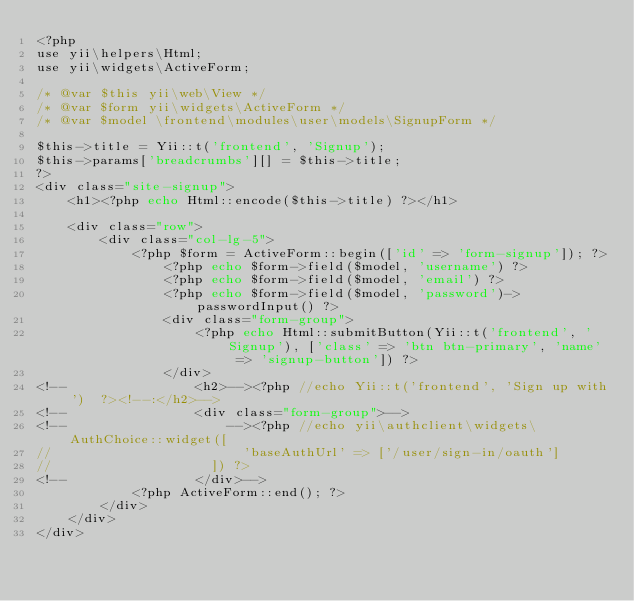Convert code to text. <code><loc_0><loc_0><loc_500><loc_500><_PHP_><?php
use yii\helpers\Html;
use yii\widgets\ActiveForm;

/* @var $this yii\web\View */
/* @var $form yii\widgets\ActiveForm */
/* @var $model \frontend\modules\user\models\SignupForm */

$this->title = Yii::t('frontend', 'Signup');
$this->params['breadcrumbs'][] = $this->title;
?>
<div class="site-signup">
    <h1><?php echo Html::encode($this->title) ?></h1>

    <div class="row">
        <div class="col-lg-5">
            <?php $form = ActiveForm::begin(['id' => 'form-signup']); ?>
                <?php echo $form->field($model, 'username') ?>
                <?php echo $form->field($model, 'email') ?>
                <?php echo $form->field($model, 'password')->passwordInput() ?>
                <div class="form-group">
                    <?php echo Html::submitButton(Yii::t('frontend', 'Signup'), ['class' => 'btn btn-primary', 'name' => 'signup-button']) ?>
                </div>
<!--                <h2>--><?php //echo Yii::t('frontend', 'Sign up with')  ?><!--:</h2>-->
<!--                <div class="form-group">-->
<!--                    --><?php //echo yii\authclient\widgets\AuthChoice::widget([
//                        'baseAuthUrl' => ['/user/sign-in/oauth']
//                    ]) ?>
<!--                </div>-->
            <?php ActiveForm::end(); ?>
        </div>
    </div>
</div>
</code> 